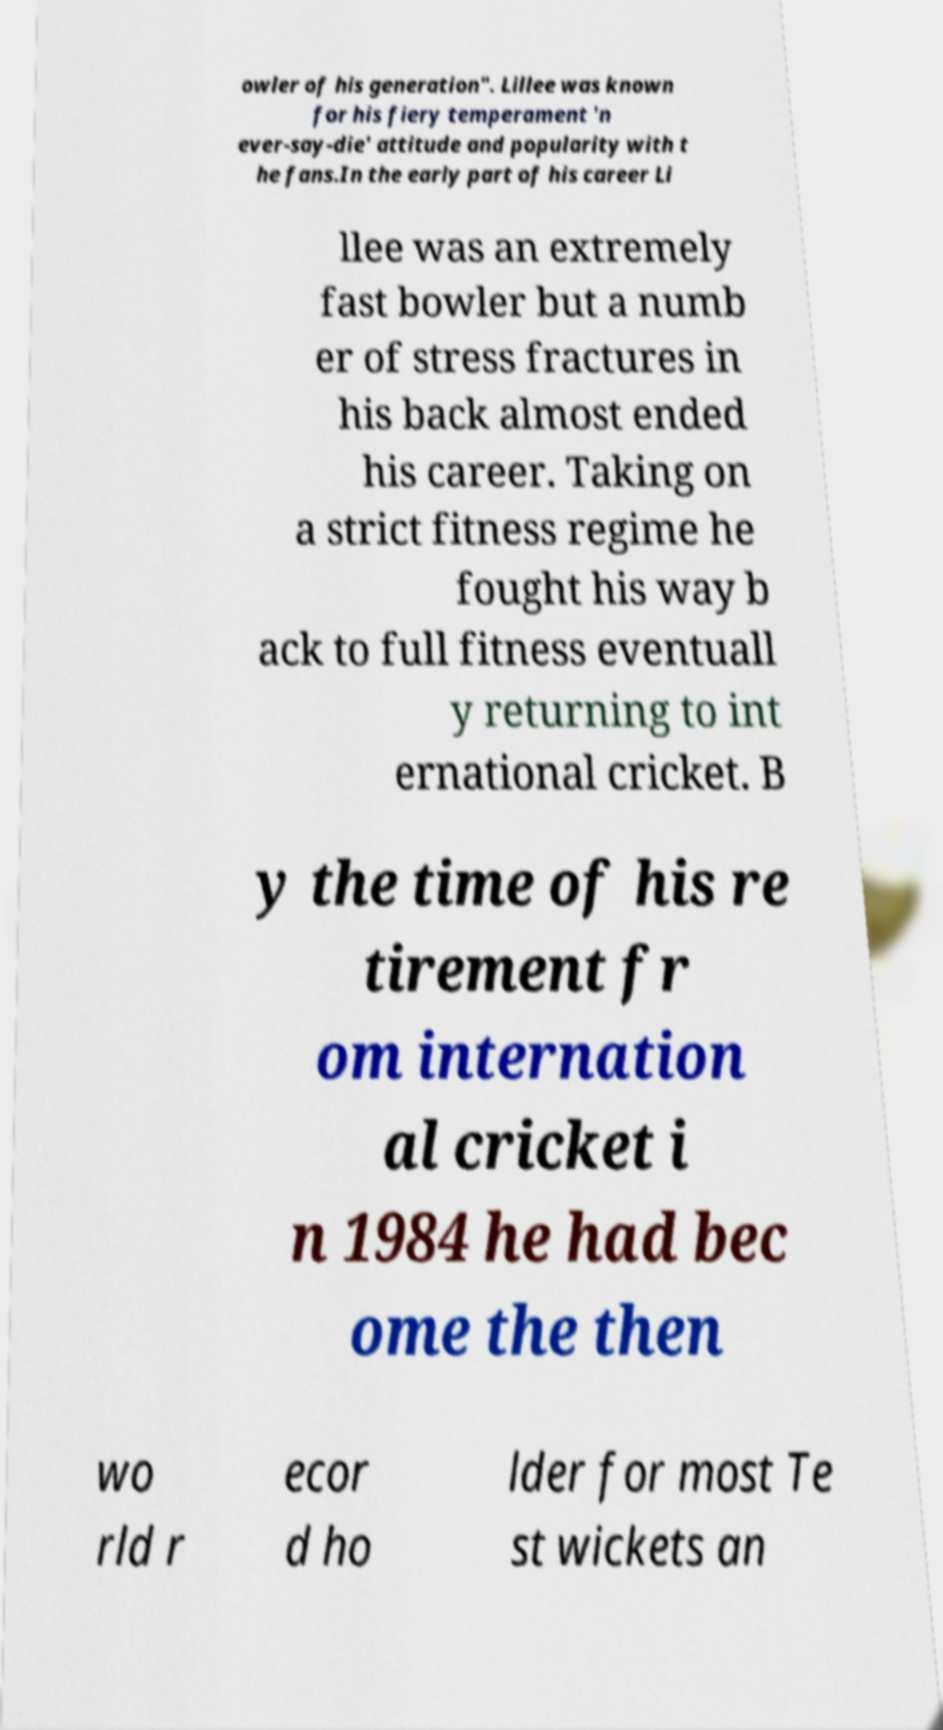Can you read and provide the text displayed in the image?This photo seems to have some interesting text. Can you extract and type it out for me? owler of his generation". Lillee was known for his fiery temperament 'n ever-say-die' attitude and popularity with t he fans.In the early part of his career Li llee was an extremely fast bowler but a numb er of stress fractures in his back almost ended his career. Taking on a strict fitness regime he fought his way b ack to full fitness eventuall y returning to int ernational cricket. B y the time of his re tirement fr om internation al cricket i n 1984 he had bec ome the then wo rld r ecor d ho lder for most Te st wickets an 